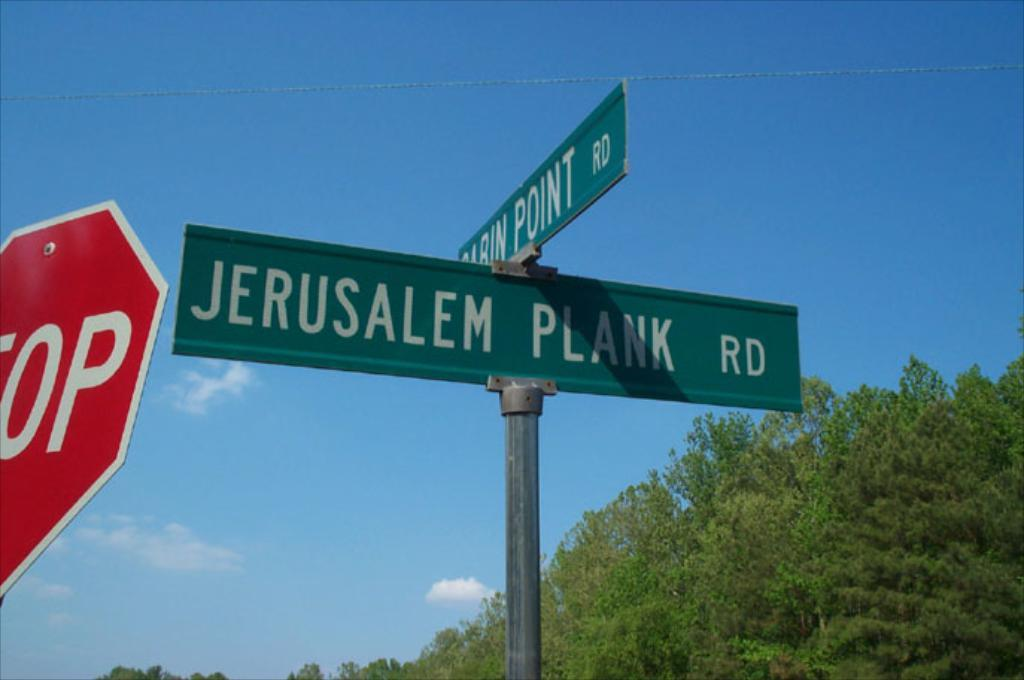<image>
Give a short and clear explanation of the subsequent image. A street sign next to a stop sign or Jerusalem Plank Road. 